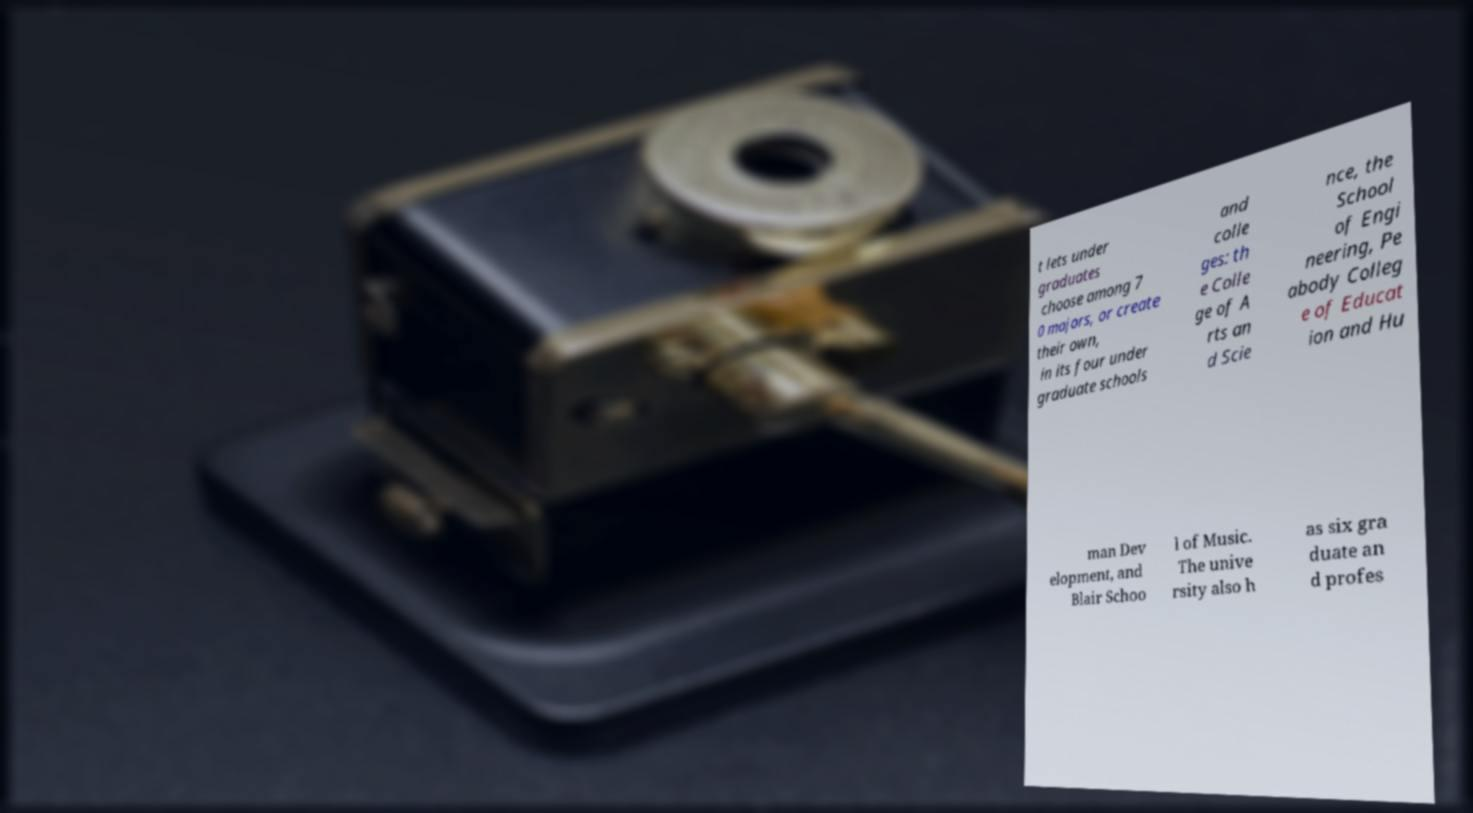For documentation purposes, I need the text within this image transcribed. Could you provide that? t lets under graduates choose among 7 0 majors, or create their own, in its four under graduate schools and colle ges: th e Colle ge of A rts an d Scie nce, the School of Engi neering, Pe abody Colleg e of Educat ion and Hu man Dev elopment, and Blair Schoo l of Music. The unive rsity also h as six gra duate an d profes 